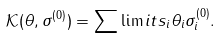Convert formula to latex. <formula><loc_0><loc_0><loc_500><loc_500>\mathcal { K } ( \theta , \sigma ^ { ( 0 ) } ) = \sum \lim i t s _ { i } \theta _ { i } \sigma ^ { ( 0 ) } _ { i } .</formula> 